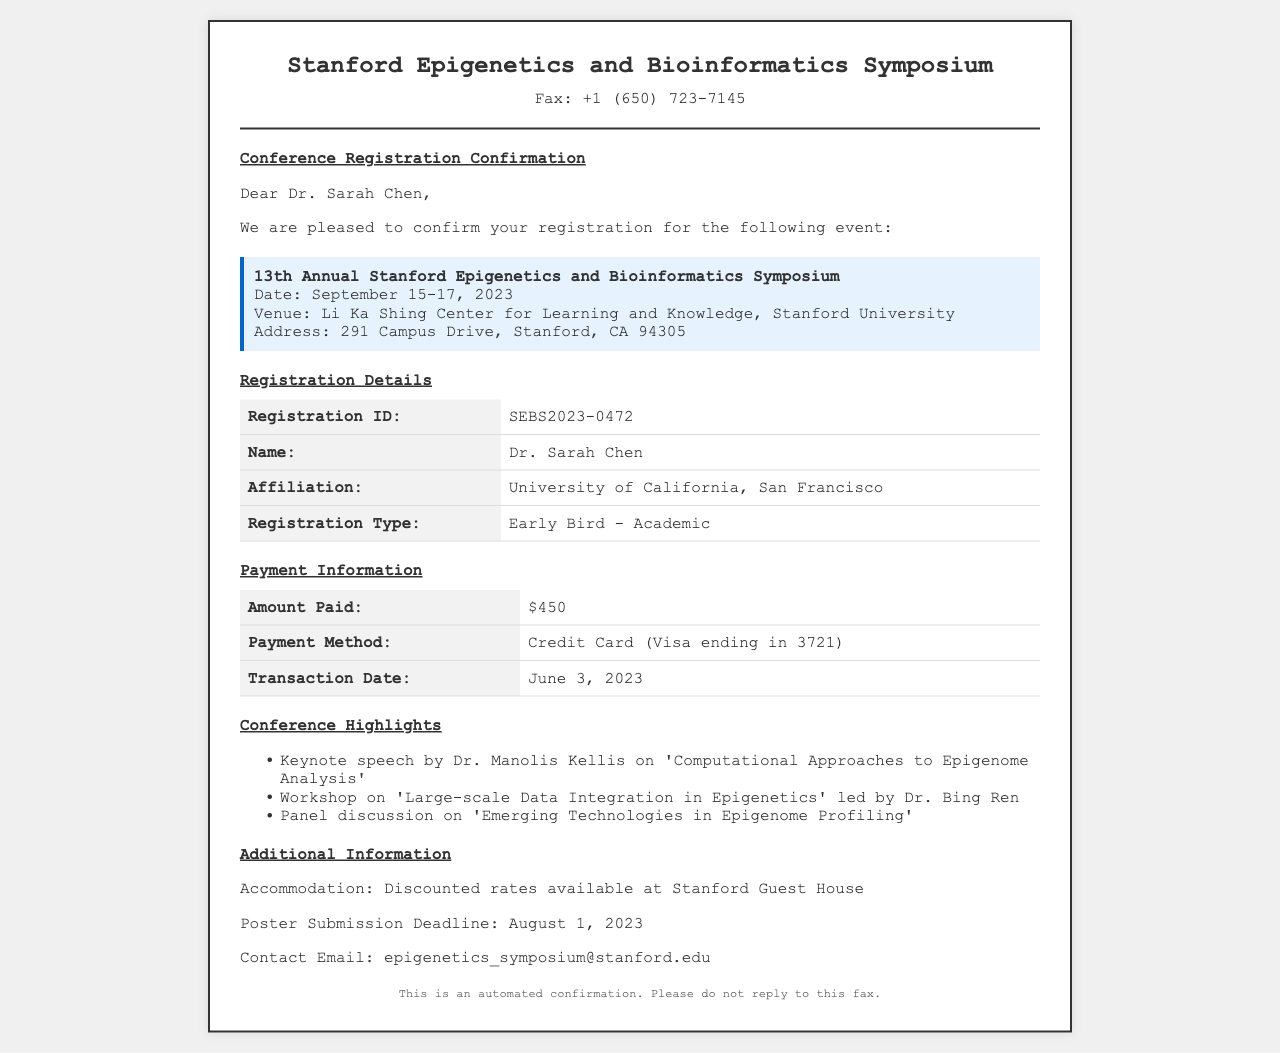What is the registration ID? The registration ID is specifically mentioned in the registration details section of the document for the attendee.
Answer: SEBS2023-0472 Who is the keynote speaker? The keynote speaker is highlighted in the conference highlights section of the document, presenting a specific topic related to epigenetics.
Answer: Dr. Manolis Kellis What is the total amount paid for registration? The total amount paid is detailed in the payment information section of the fax document.
Answer: $450 What date does the symposium start? The start date of the symposium is clearly stated in the event details section of the document.
Answer: September 15, 2023 What type of registration did Dr. Sarah Chen choose? This information is outlined in the registration details section, specifying the category of registration.
Answer: Early Bird - Academic Where is the symposium being held? The venue of the symposium is specified in the event details section, indicating the location.
Answer: Li Ka Shing Center for Learning and Knowledge, Stanford University What is the poster submission deadline? The deadline for poster submission is provided in the additional information section of the fax.
Answer: August 1, 2023 What is the contact email for the symposium? The contact email is mentioned in the additional information section to reach out for inquiries.
Answer: epigenetics_symposium@stanford.edu Is the fax addressed to a specific person? The document includes a greeting at the beginning, indicating who it is addressed to, thus confirming the information.
Answer: Dr. Sarah Chen 